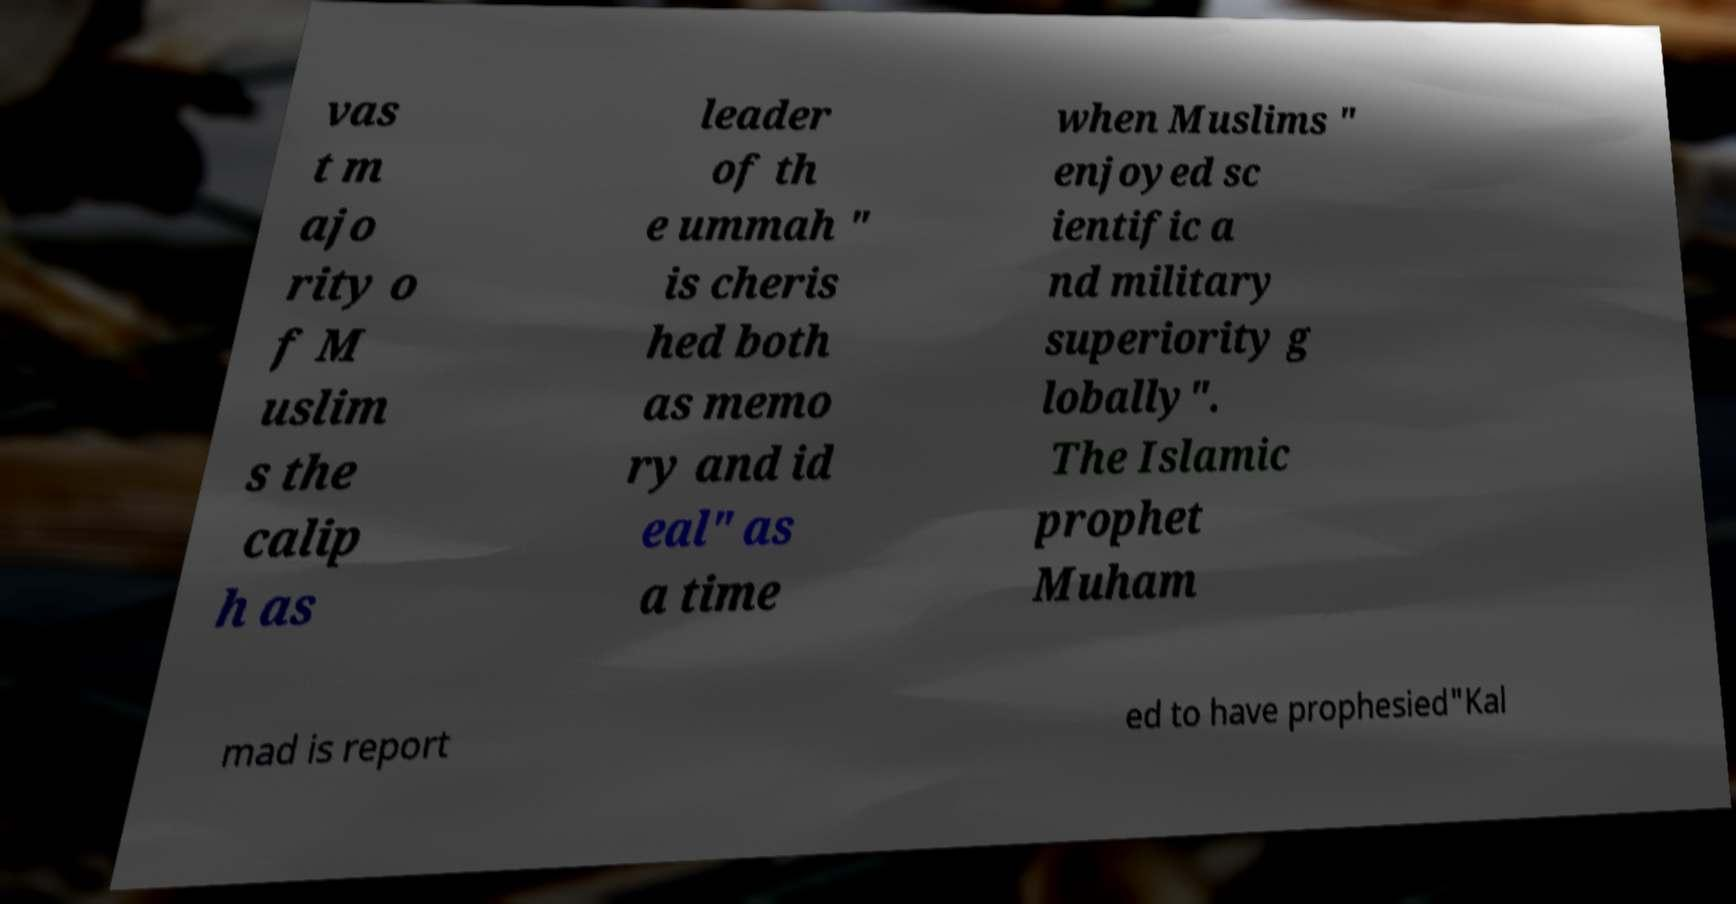Can you read and provide the text displayed in the image?This photo seems to have some interesting text. Can you extract and type it out for me? vas t m ajo rity o f M uslim s the calip h as leader of th e ummah " is cheris hed both as memo ry and id eal" as a time when Muslims " enjoyed sc ientific a nd military superiority g lobally". The Islamic prophet Muham mad is report ed to have prophesied"Kal 